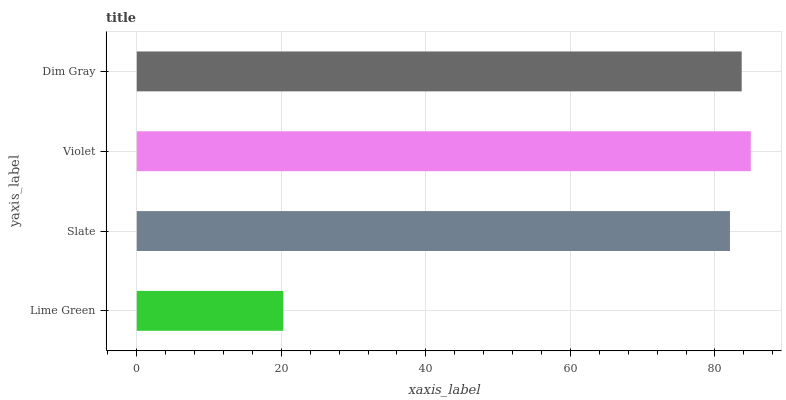Is Lime Green the minimum?
Answer yes or no. Yes. Is Violet the maximum?
Answer yes or no. Yes. Is Slate the minimum?
Answer yes or no. No. Is Slate the maximum?
Answer yes or no. No. Is Slate greater than Lime Green?
Answer yes or no. Yes. Is Lime Green less than Slate?
Answer yes or no. Yes. Is Lime Green greater than Slate?
Answer yes or no. No. Is Slate less than Lime Green?
Answer yes or no. No. Is Dim Gray the high median?
Answer yes or no. Yes. Is Slate the low median?
Answer yes or no. Yes. Is Slate the high median?
Answer yes or no. No. Is Dim Gray the low median?
Answer yes or no. No. 